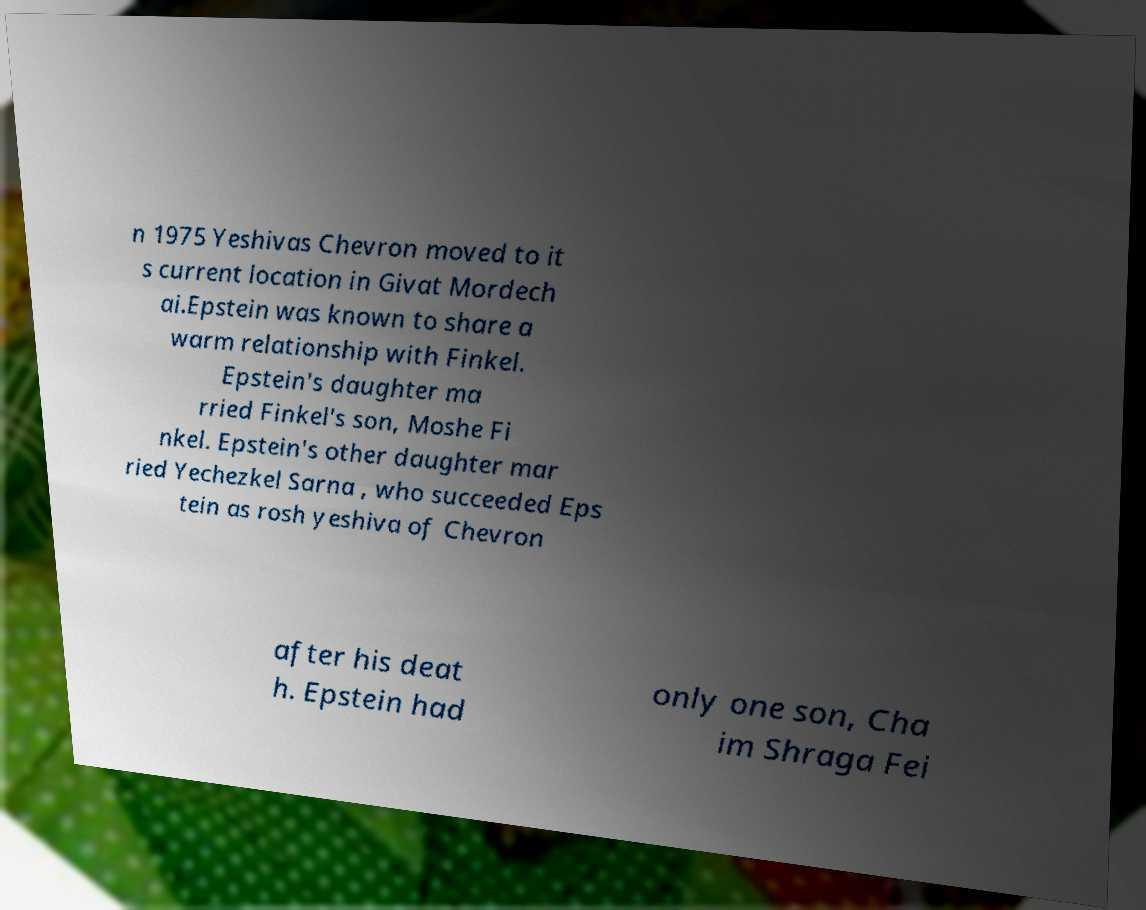For documentation purposes, I need the text within this image transcribed. Could you provide that? n 1975 Yeshivas Chevron moved to it s current location in Givat Mordech ai.Epstein was known to share a warm relationship with Finkel. Epstein's daughter ma rried Finkel's son, Moshe Fi nkel. Epstein's other daughter mar ried Yechezkel Sarna , who succeeded Eps tein as rosh yeshiva of Chevron after his deat h. Epstein had only one son, Cha im Shraga Fei 